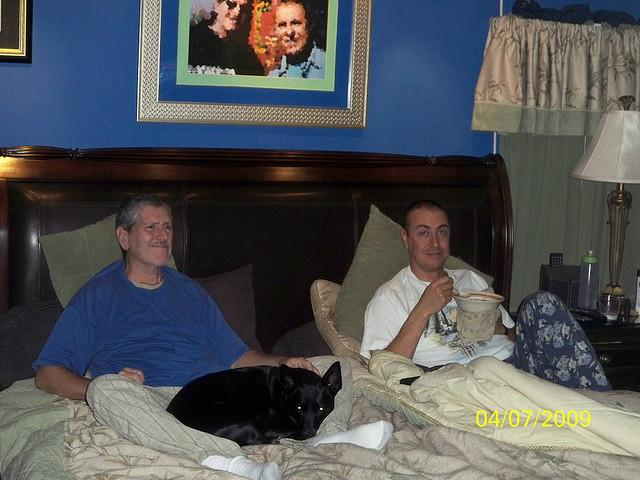How are these men related? Please explain your reasoning. lovers. The men are lovers. 